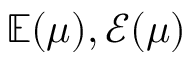Convert formula to latex. <formula><loc_0><loc_0><loc_500><loc_500>\mathbb { E } ( \mu ) , \mathcal { E } ( \mu )</formula> 